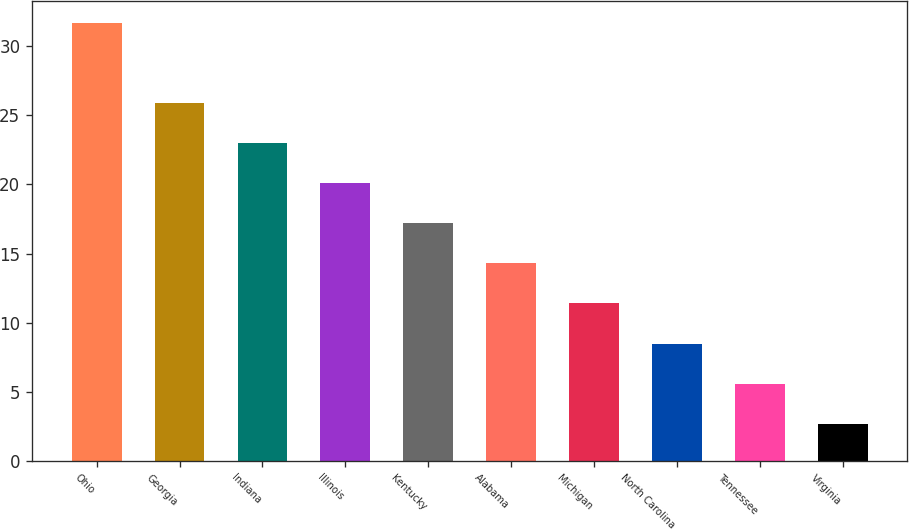<chart> <loc_0><loc_0><loc_500><loc_500><bar_chart><fcel>Ohio<fcel>Georgia<fcel>Indiana<fcel>Illinois<fcel>Kentucky<fcel>Alabama<fcel>Michigan<fcel>North Carolina<fcel>Tennessee<fcel>Virginia<nl><fcel>31.7<fcel>25.9<fcel>23<fcel>20.1<fcel>17.2<fcel>14.3<fcel>11.4<fcel>8.5<fcel>5.6<fcel>2.7<nl></chart> 